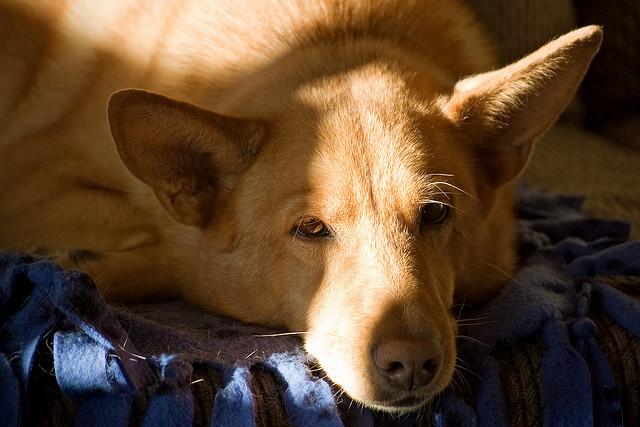What is the color of the dogs?
Write a very short answer. Brown. Is the dog sleepy?
Be succinct. Yes. Is the dog sad?
Write a very short answer. No. What color are the dog's eyes?
Give a very brief answer. Brown. What animal is in the image?
Keep it brief. Dog. 